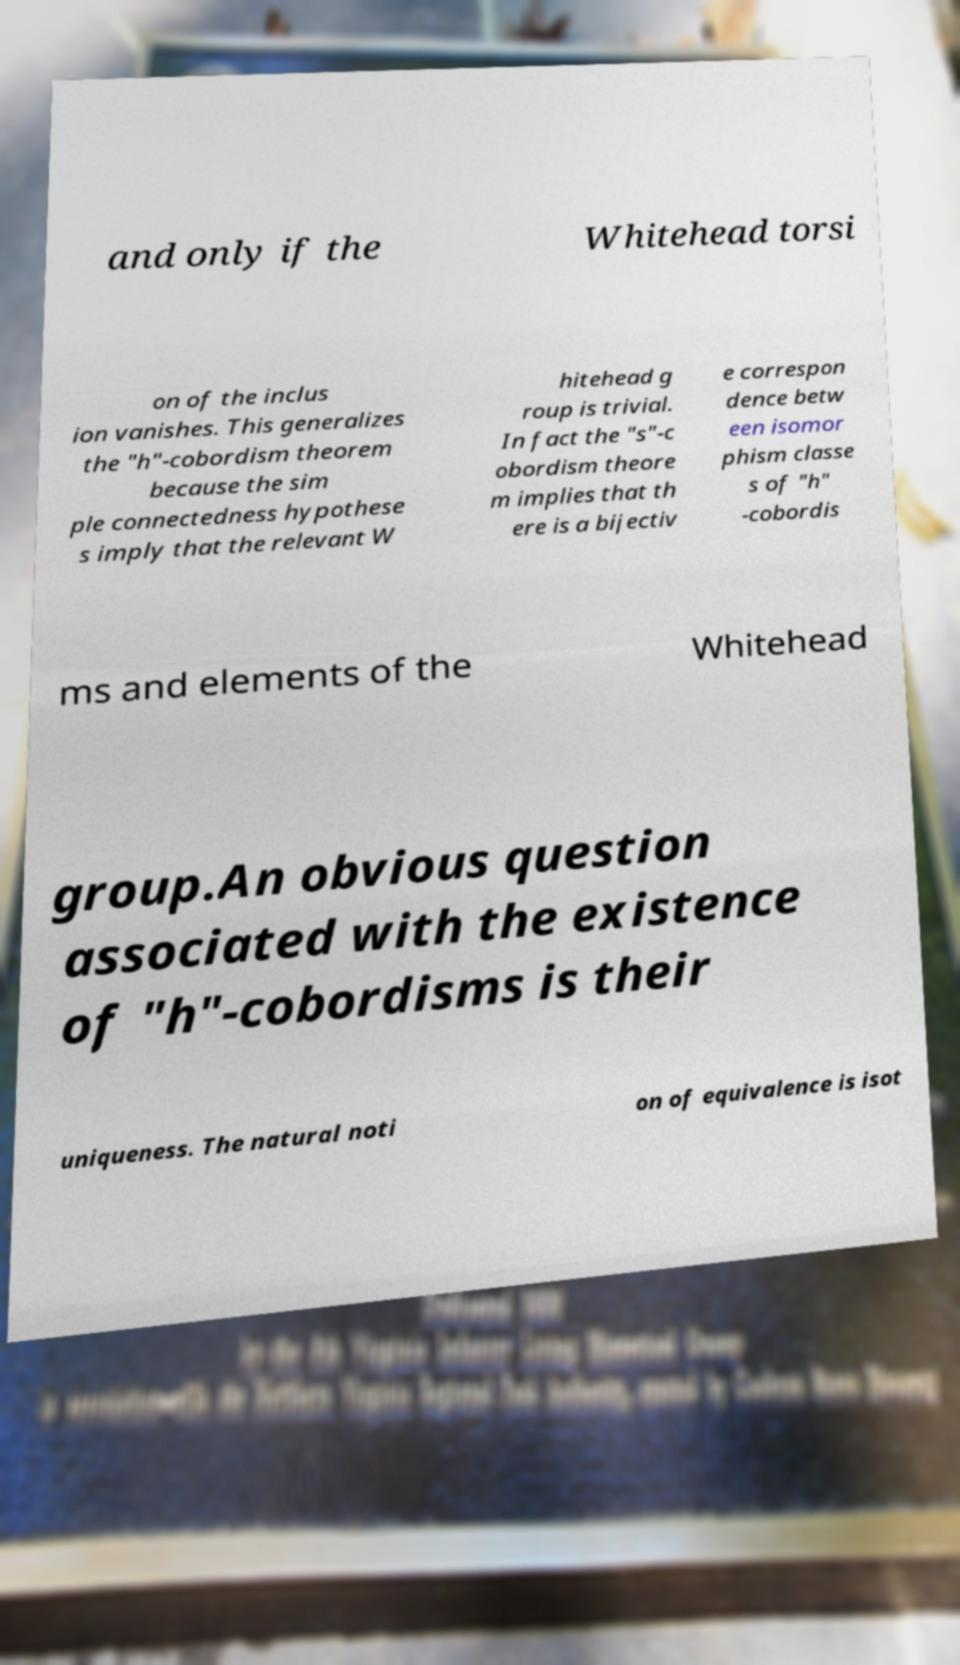What messages or text are displayed in this image? I need them in a readable, typed format. and only if the Whitehead torsi on of the inclus ion vanishes. This generalizes the "h"-cobordism theorem because the sim ple connectedness hypothese s imply that the relevant W hitehead g roup is trivial. In fact the "s"-c obordism theore m implies that th ere is a bijectiv e correspon dence betw een isomor phism classe s of "h" -cobordis ms and elements of the Whitehead group.An obvious question associated with the existence of "h"-cobordisms is their uniqueness. The natural noti on of equivalence is isot 